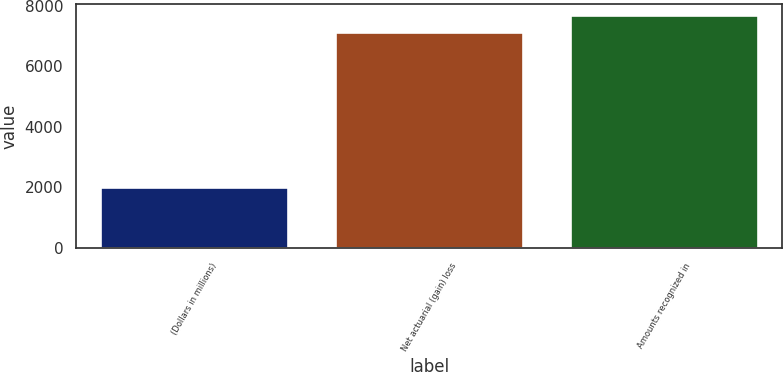<chart> <loc_0><loc_0><loc_500><loc_500><bar_chart><fcel>(Dollars in millions)<fcel>Net actuarial (gain) loss<fcel>Amounts recognized in<nl><fcel>2008<fcel>7144<fcel>7680.1<nl></chart> 